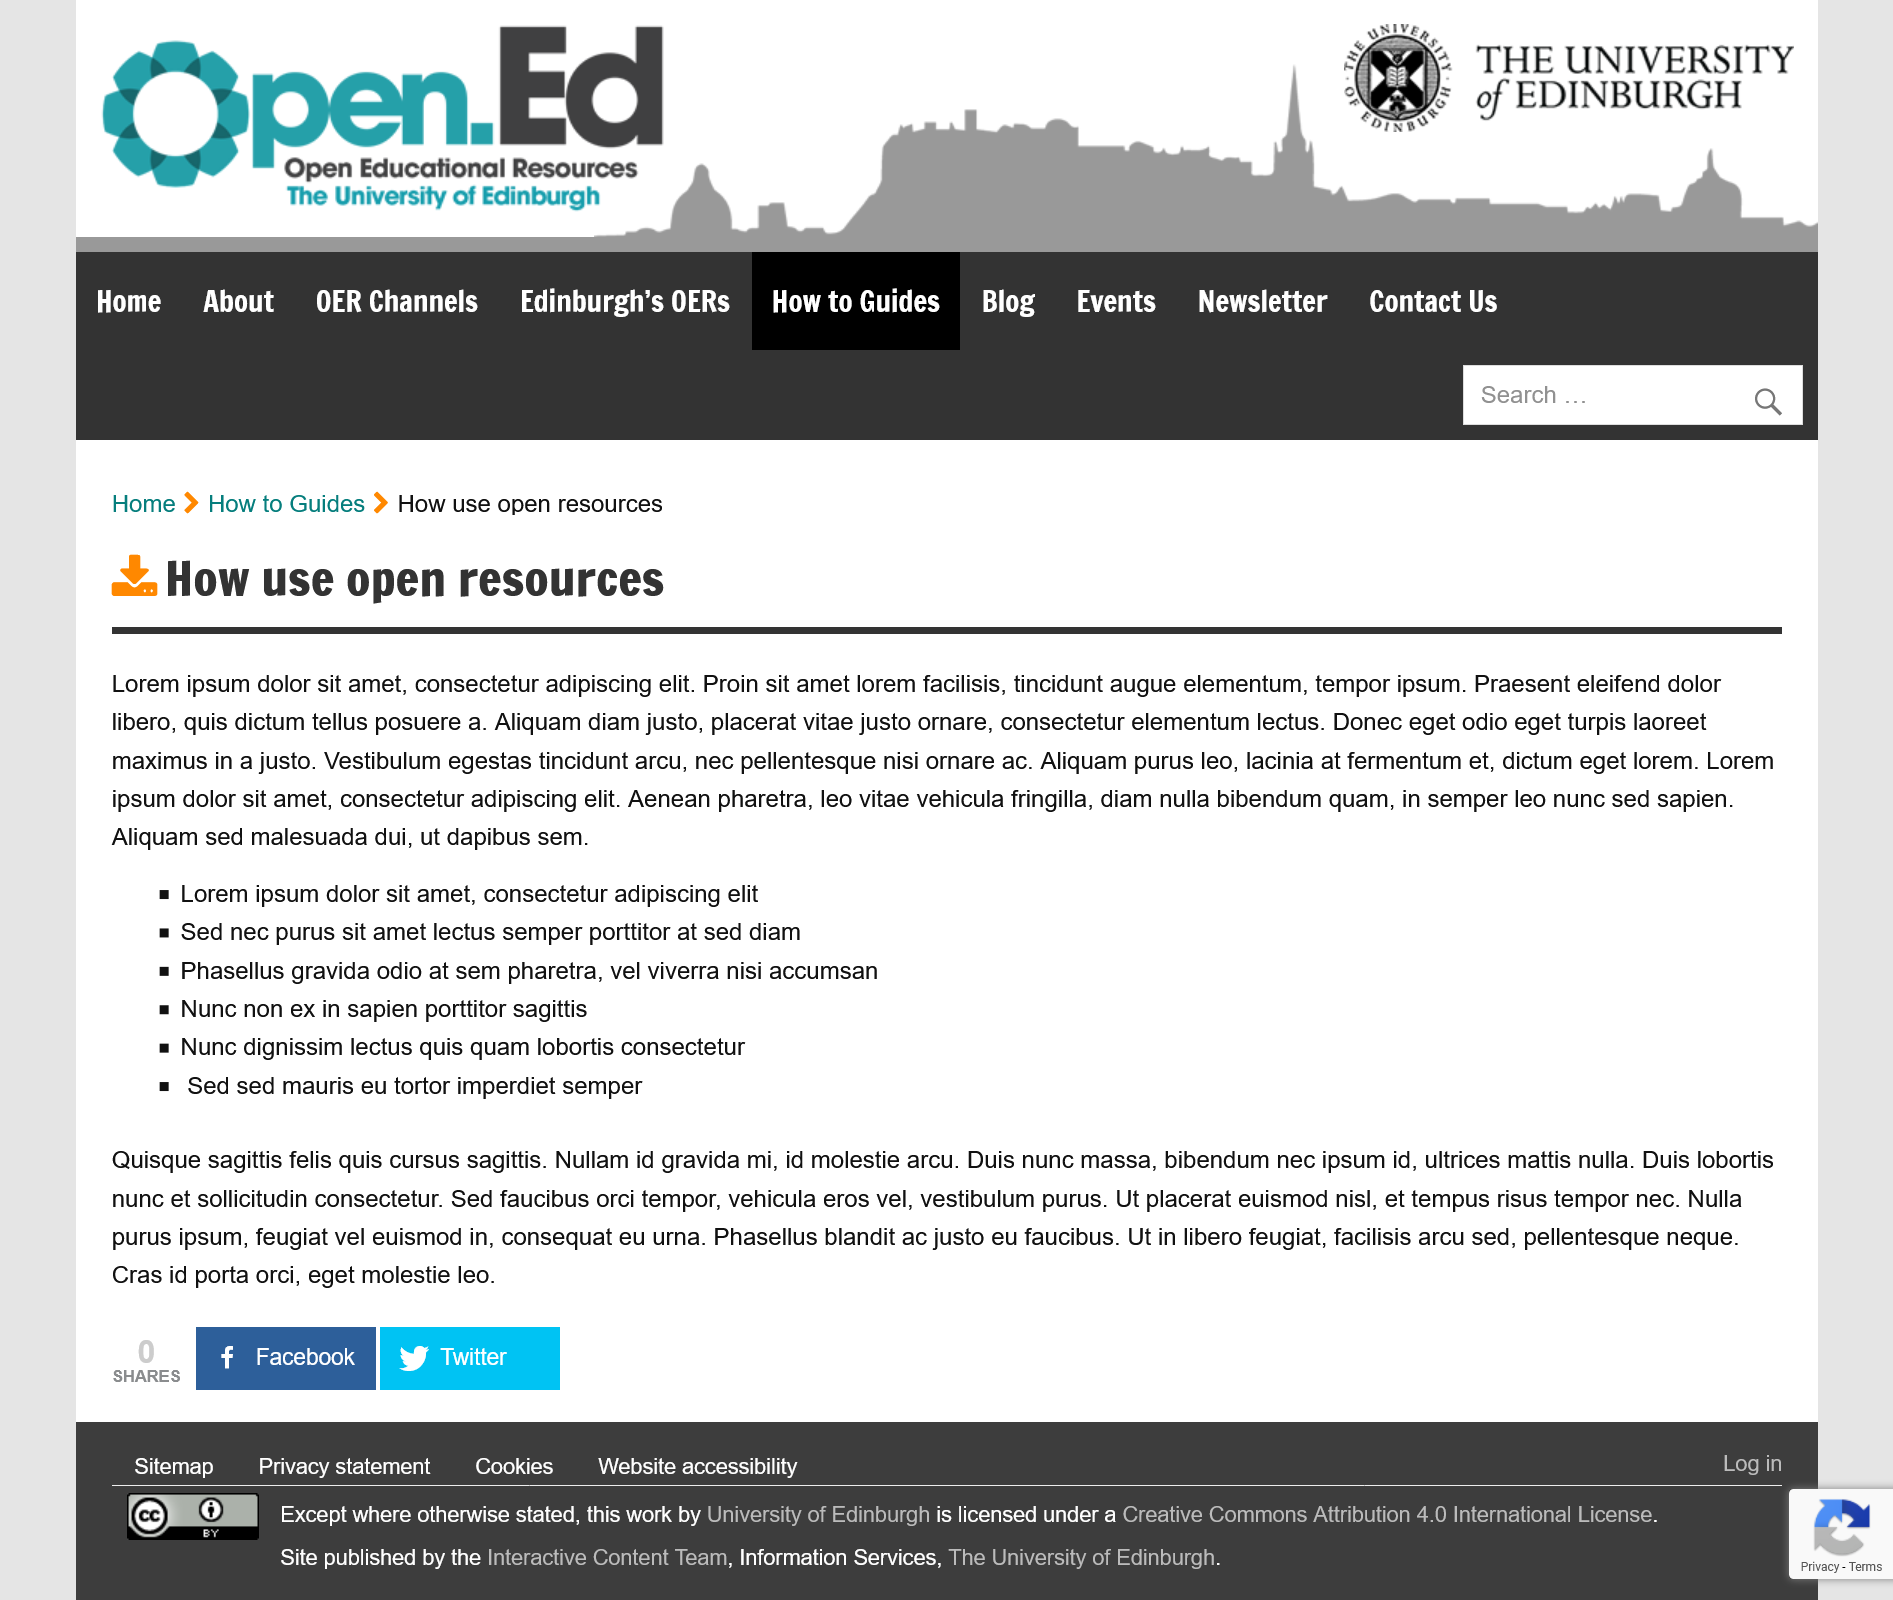List a handful of essential elements in this visual. The information given in the article is entirely in Japanese, with no English translation provided. The title of the article that includes the Latin placeholder text as its information is 'How to Use Open Resources.' There are six bullet points in this article. 